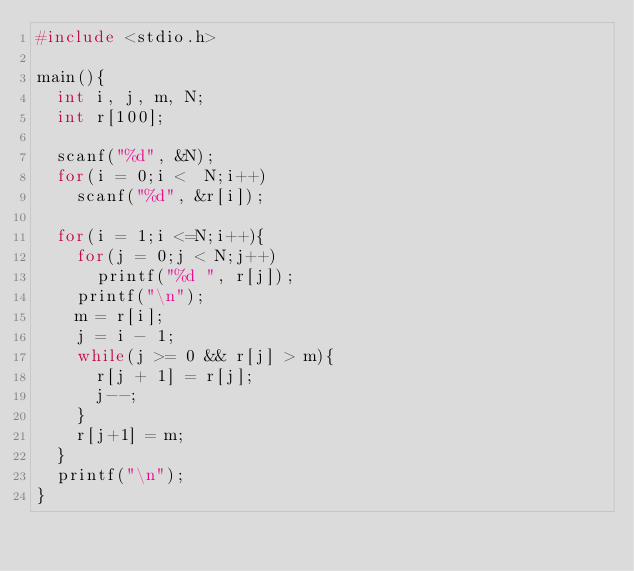<code> <loc_0><loc_0><loc_500><loc_500><_C_>#include <stdio.h>

main(){
  int i, j, m, N;
  int r[100];

  scanf("%d", &N);
  for(i = 0;i <  N;i++)
    scanf("%d", &r[i]);

  for(i = 1;i <=N;i++){
    for(j = 0;j < N;j++)
      printf("%d ", r[j]);
    printf("\n");
    m = r[i];
    j = i - 1;
    while(j >= 0 && r[j] > m){
      r[j + 1] = r[j];
      j--;
    }
    r[j+1] = m;
  }
  printf("\n");
}</code> 